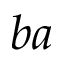<formula> <loc_0><loc_0><loc_500><loc_500>b a</formula> 